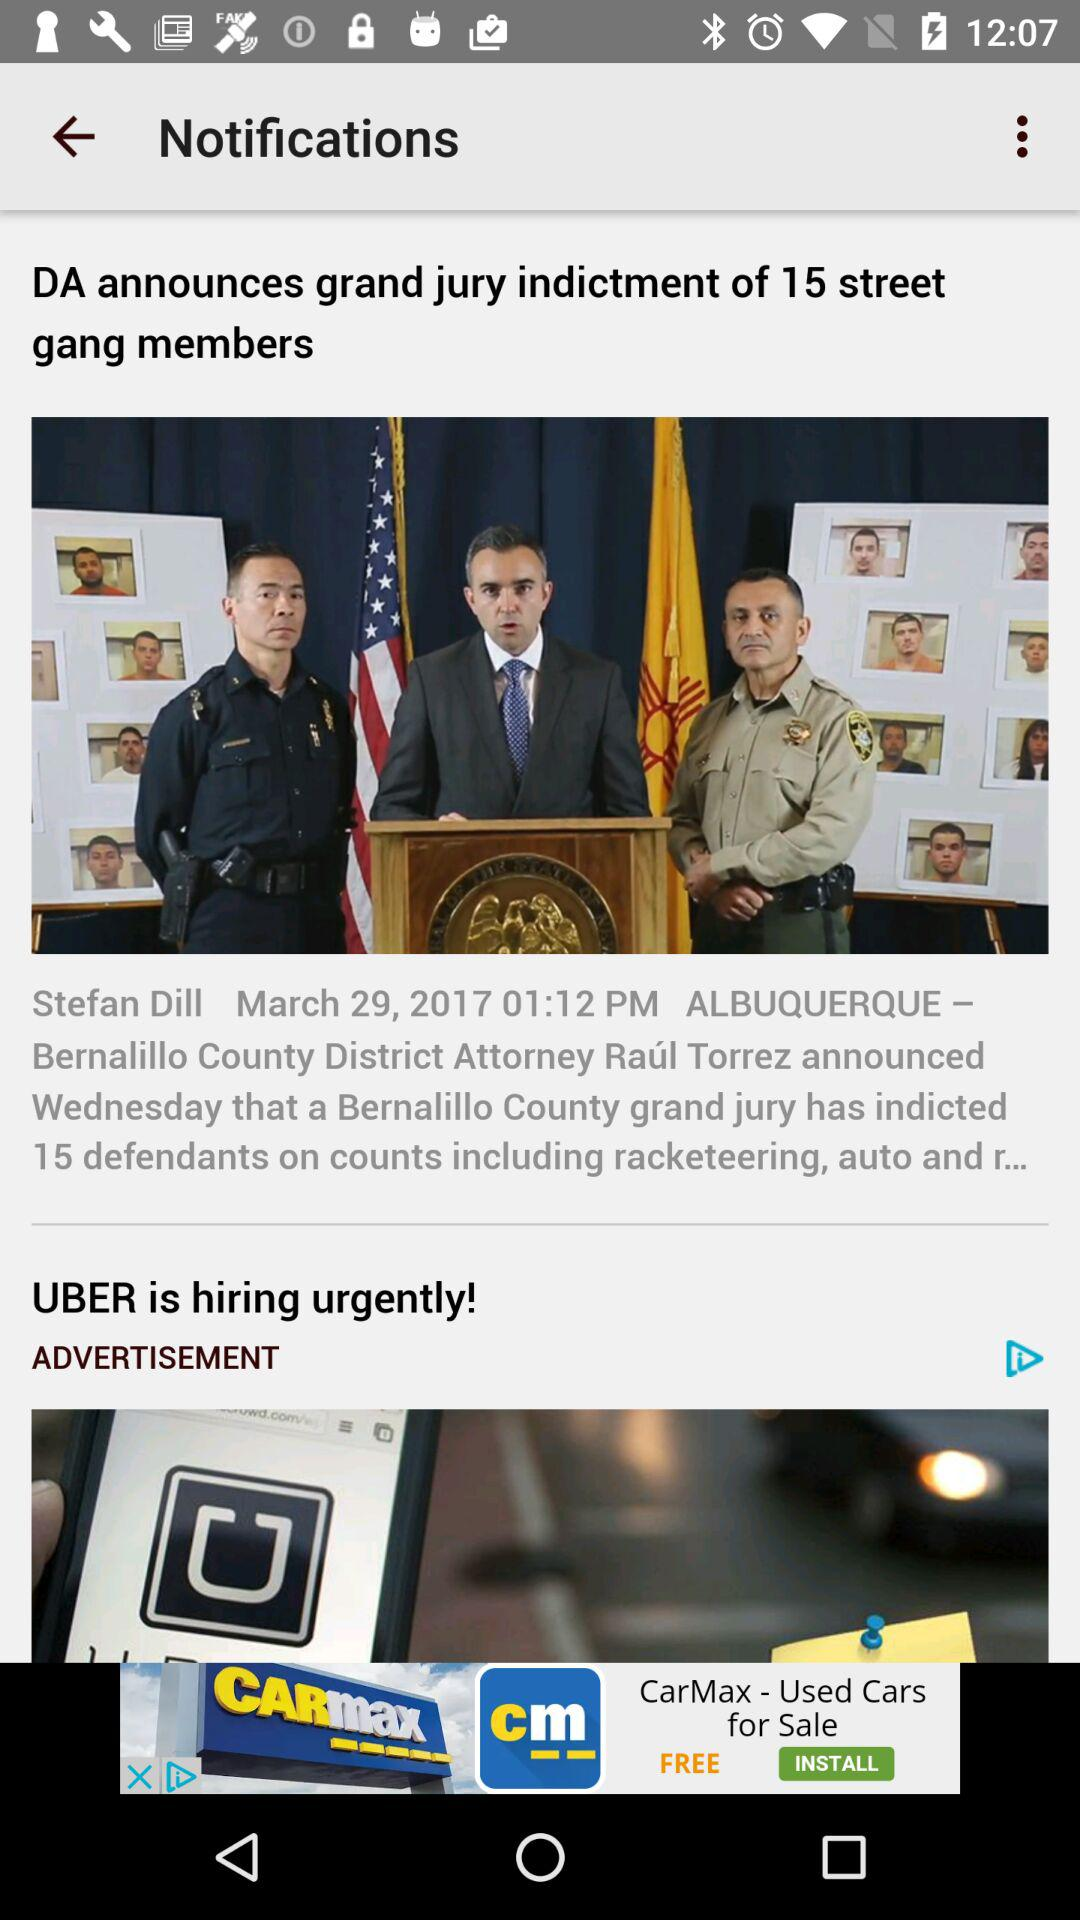What is the time? The time is 01:12 PM. 